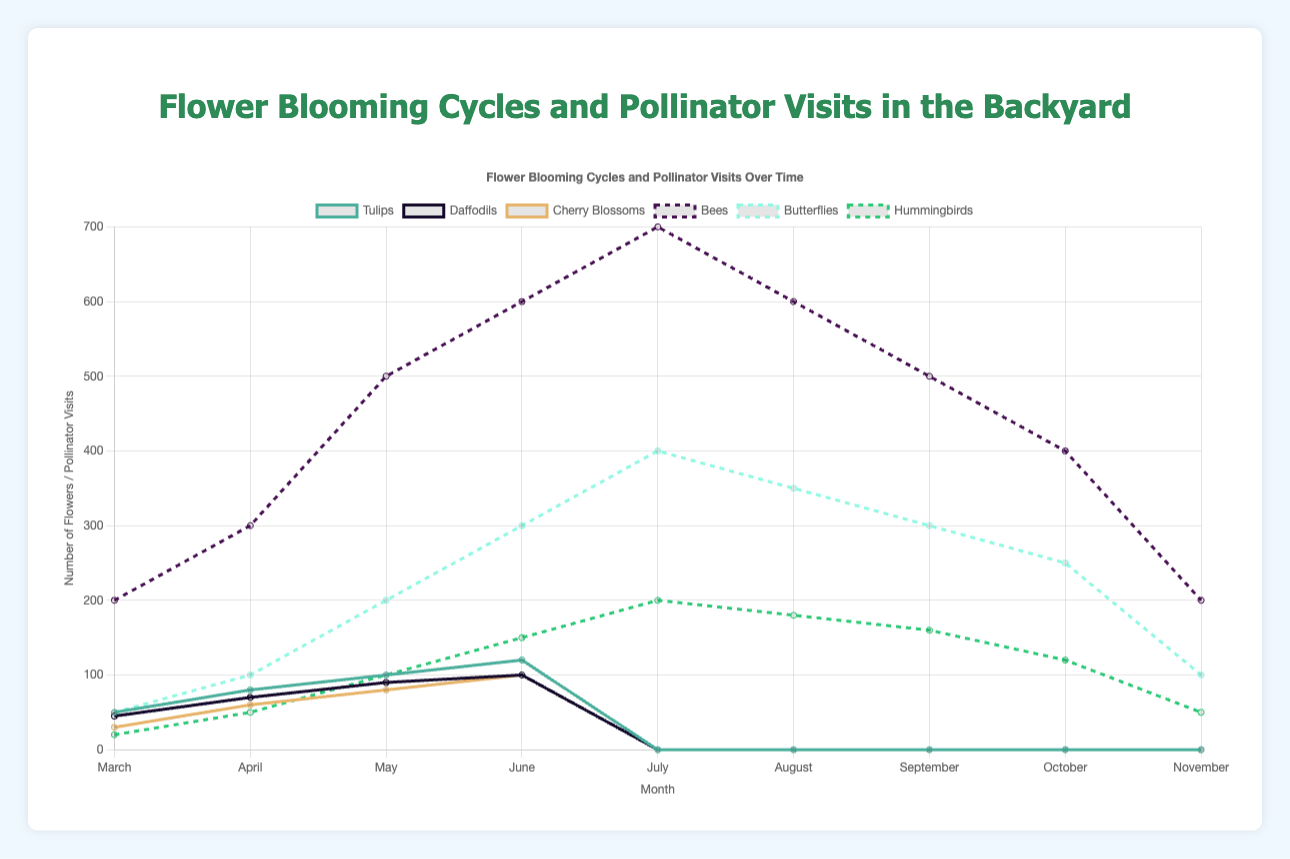What month has the highest number of Tulips blooming? In the figure, the line representing Tulips can be observed. By inspecting the plot, we see that the peak of the Tulip blooming occurs in June.
Answer: June Which pollinator has the most visits in July? By analyzing the multiple lines corresponding to pollinators, we identify that the line for Bees is the highest in July.
Answer: Bees How many total (sum) Daffodils bloomed from March to June? Sum up the values for each month: March (45) + April (70) + May (90) + June (100) = 305.
Answer: 305 Compare the number of Lilies in May and July. Which month has more? Follow the line representing Lilies and inspect the values at May and July. May has 70, and July has 100. July has more Lilies.
Answer: July What is the difference in the number of pollinator visits by Hummingbirds between August and September? Inspect the line for Hummingbirds: August (180) - September (160) = 20.
Answer: 20 How does the pattern of Bees visits change from April to August? Follow the Bees line from April (300) to August (600) and observe a steady increase with Bees visits peaking in July (700) before decreasing again.
Answer: Increases then decreases What month sees the introduction of the first bloom for Roses? Identify the starting point of the Rose's line on the plot, which begins in May.
Answer: May How does the number of Lavender blooms compare between June and September? Look at the Lavender line: June has 60, and September has 70. September has more blooms.
Answer: September What is the total number of flowers bloomed in July? Add up the flowers in July: Lilies (100) + Roses (120) + Lavender (90) + Sunflowers (60) + Marigolds (40) = 410.
Answer: 410 How many pollinators visit in total in October? Add up pollinator visits in October: Bees (400) + Butterflies (250) + Hummingbirds (120) = 770.
Answer: 770 